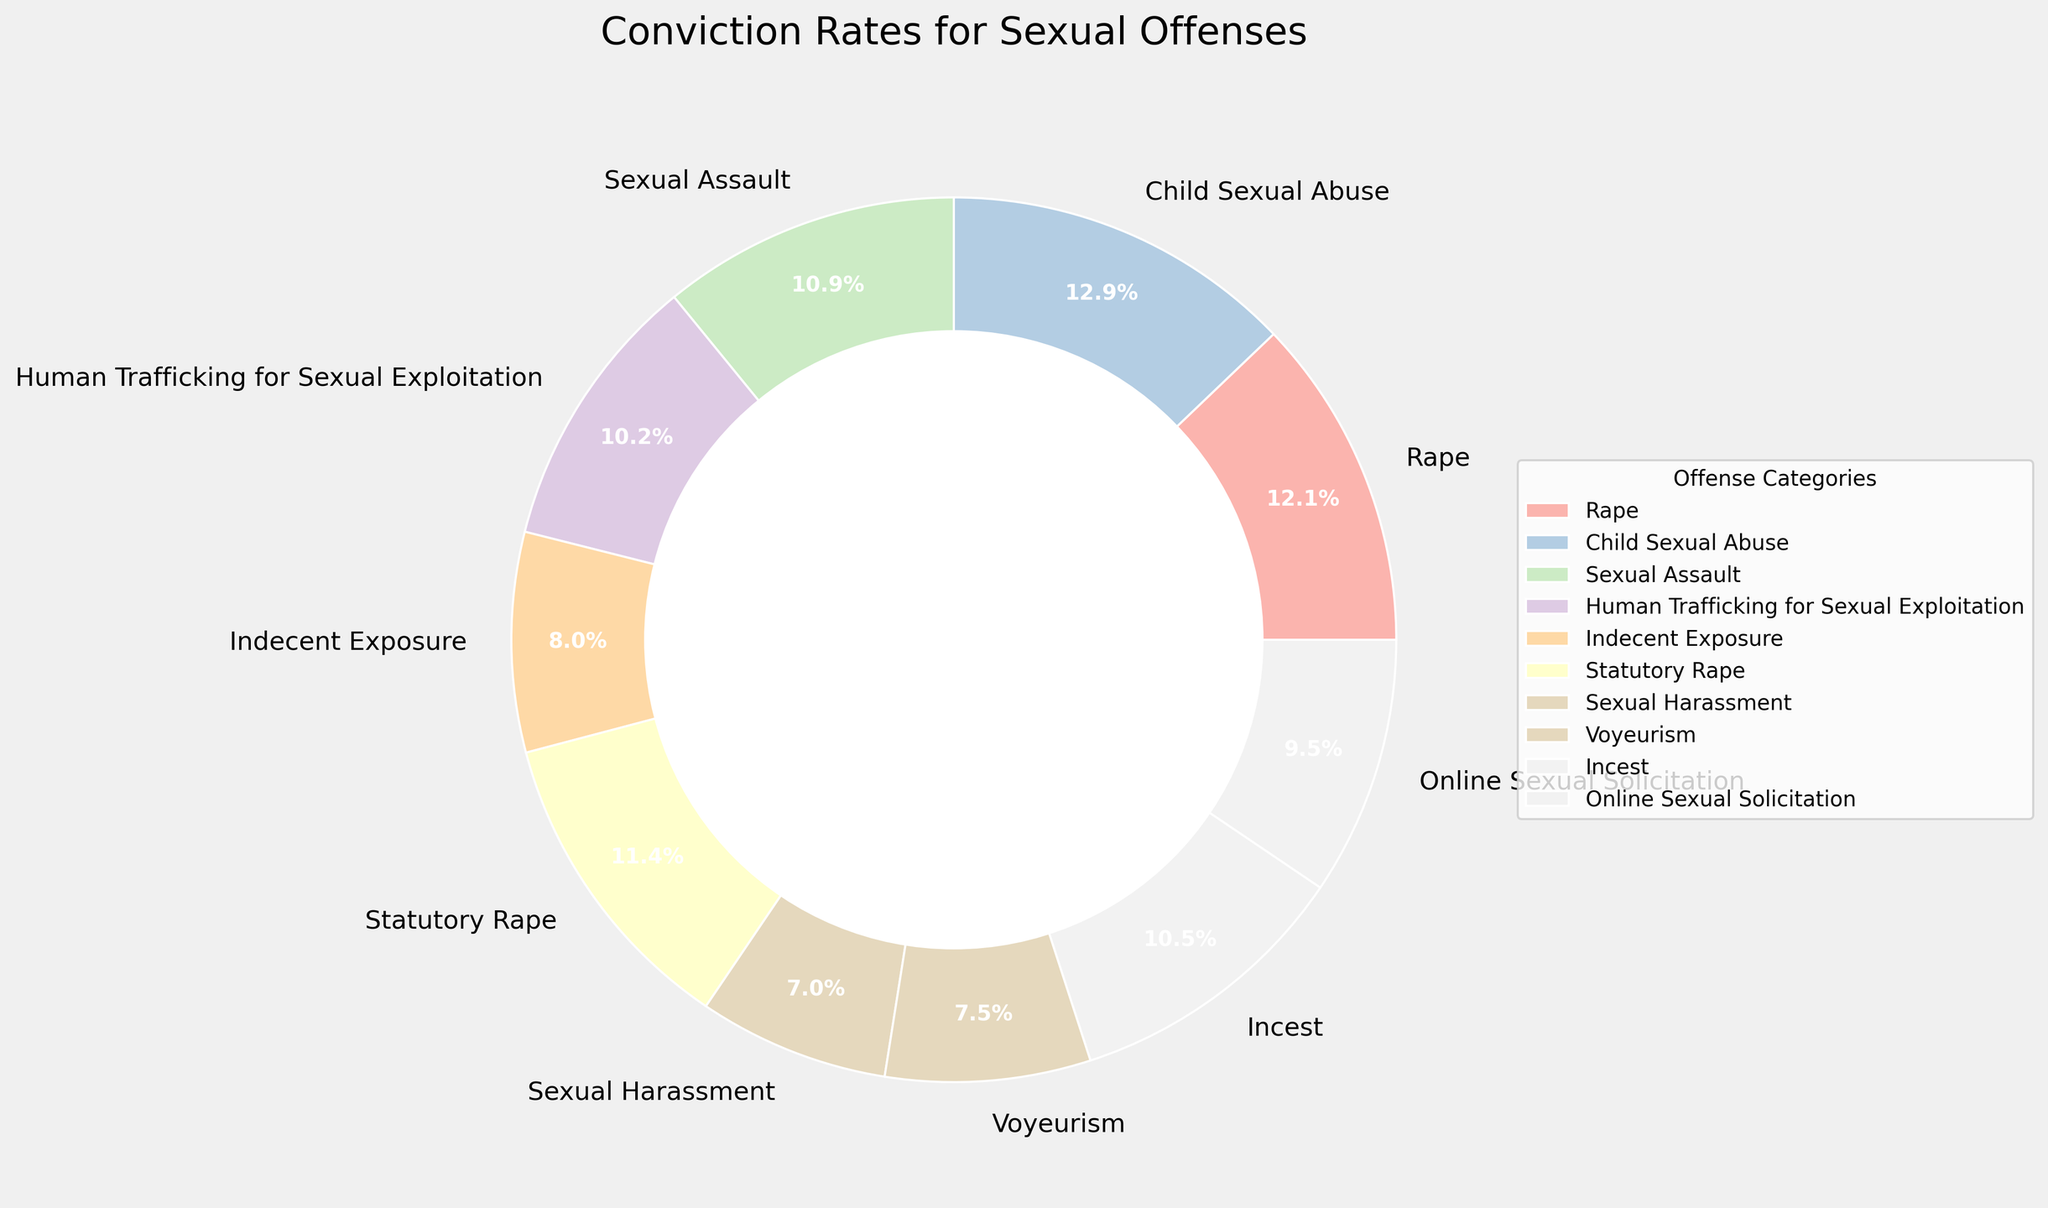What is the category with the highest conviction rate? First, identify the conviction rates for each category from the figure. The category with the highest percentage is the one with the highest conviction rate. In this case, Child Sexual Abuse has the highest conviction rate at 72%.
Answer: Child Sexual Abuse Which offense category has the lowest conviction rate? Look at the conviction rates provided for all categories and identify the smallest percentage. The lowest conviction rate is for Sexual Harassment at 39%.
Answer: Sexual Harassment How much higher is the conviction rate for Rape compared to Sexual Harassment? Find the conviction rates for both Rape and Sexual Harassment. Subtract the conviction rate of Sexual Harassment (39%) from that of Rape (68%). The difference is 68% - 39% = 29%.
Answer: 29% What is the average conviction rate of all listed offense categories? Sum all the conviction rates (68, 72, 61, 57, 45, 64, 39, 42, 59, 53) which gives a total of 560. Divide this sum by the number of categories (10). The average conviction rate is 560 / 10 = 56%.
Answer: 56% How does the conviction rate of Incest compare to Online Sexual Solicitation? Identify the conviction rates for both Incest (59%) and Online Sexual Solicitation (53%). Incest has a higher conviction rate by 6% (59% - 53%).
Answer: 6% What is the combined conviction rate of the categories with the three lowest conviction rates? Identify the three lowest conviction rates: Sexual Harassment (39%), Voyeurism (42%), and Indecent Exposure (45%). Sum these rates: 39% + 42% + 45% = 126%.
Answer: 126% Which categories have a conviction rate higher than 60%? List all categories with conviction rates over 60% which are Rape (68%), Child Sexual Abuse (72%), Statutory Rape (64%), and Sexual Assault (61%).
Answer: Rape, Child Sexual Abuse, Statutory Rape, Sexual Assault Comparing Human Trafficking for Sexual Exploitation and Sexual Assault, which has a higher conviction rate and by how much? Find the conviction rates for Human Trafficking for Sexual Exploitation (57%) and Sexual Assault (61%). Sexual Assault has a higher rate by 4% (61% - 57%).
Answer: Sexual Assault by 4% Of the categories with conviction rates below 50%, which has the second lowest rate? Identify categories with rates below 50%: Sexual Harassment (39%), Voyeurism (42%), Indecent Exposure (45%). Voyeurism has the second lowest rate at 42%.
Answer: Voyeurism What is the median conviction rate of the offense categories listed? Arrange the conviction rates in ascending order: 39%, 42%, 45%, 53%, 57%, 59%, 61%, 64%, 68%, 72%. With 10 values, the median is the average of the 5th and 6th values: (57% + 59%)/2 = 58%.
Answer: 58% 